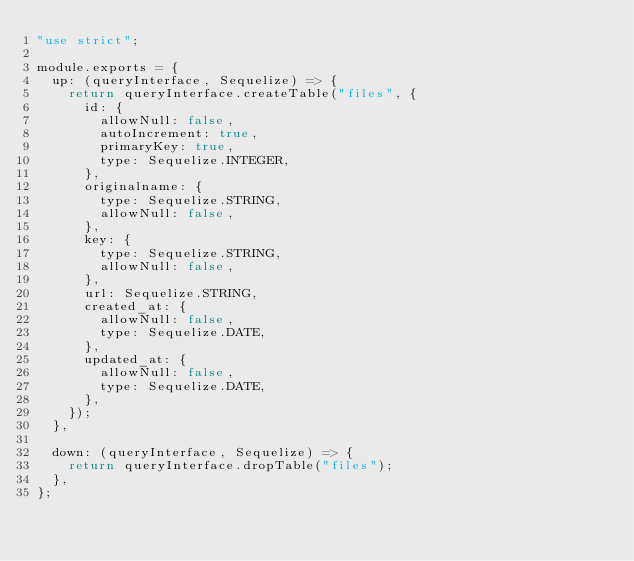<code> <loc_0><loc_0><loc_500><loc_500><_JavaScript_>"use strict";

module.exports = {
  up: (queryInterface, Sequelize) => {
    return queryInterface.createTable("files", {
      id: {
        allowNull: false,
        autoIncrement: true,
        primaryKey: true,
        type: Sequelize.INTEGER,
      },
      originalname: {
        type: Sequelize.STRING,
        allowNull: false,
      },
      key: {
        type: Sequelize.STRING,
        allowNull: false,
      },
      url: Sequelize.STRING,
      created_at: {
        allowNull: false,
        type: Sequelize.DATE,
      },
      updated_at: {
        allowNull: false,
        type: Sequelize.DATE,
      },
    });
  },

  down: (queryInterface, Sequelize) => {
    return queryInterface.dropTable("files");
  },
};
</code> 